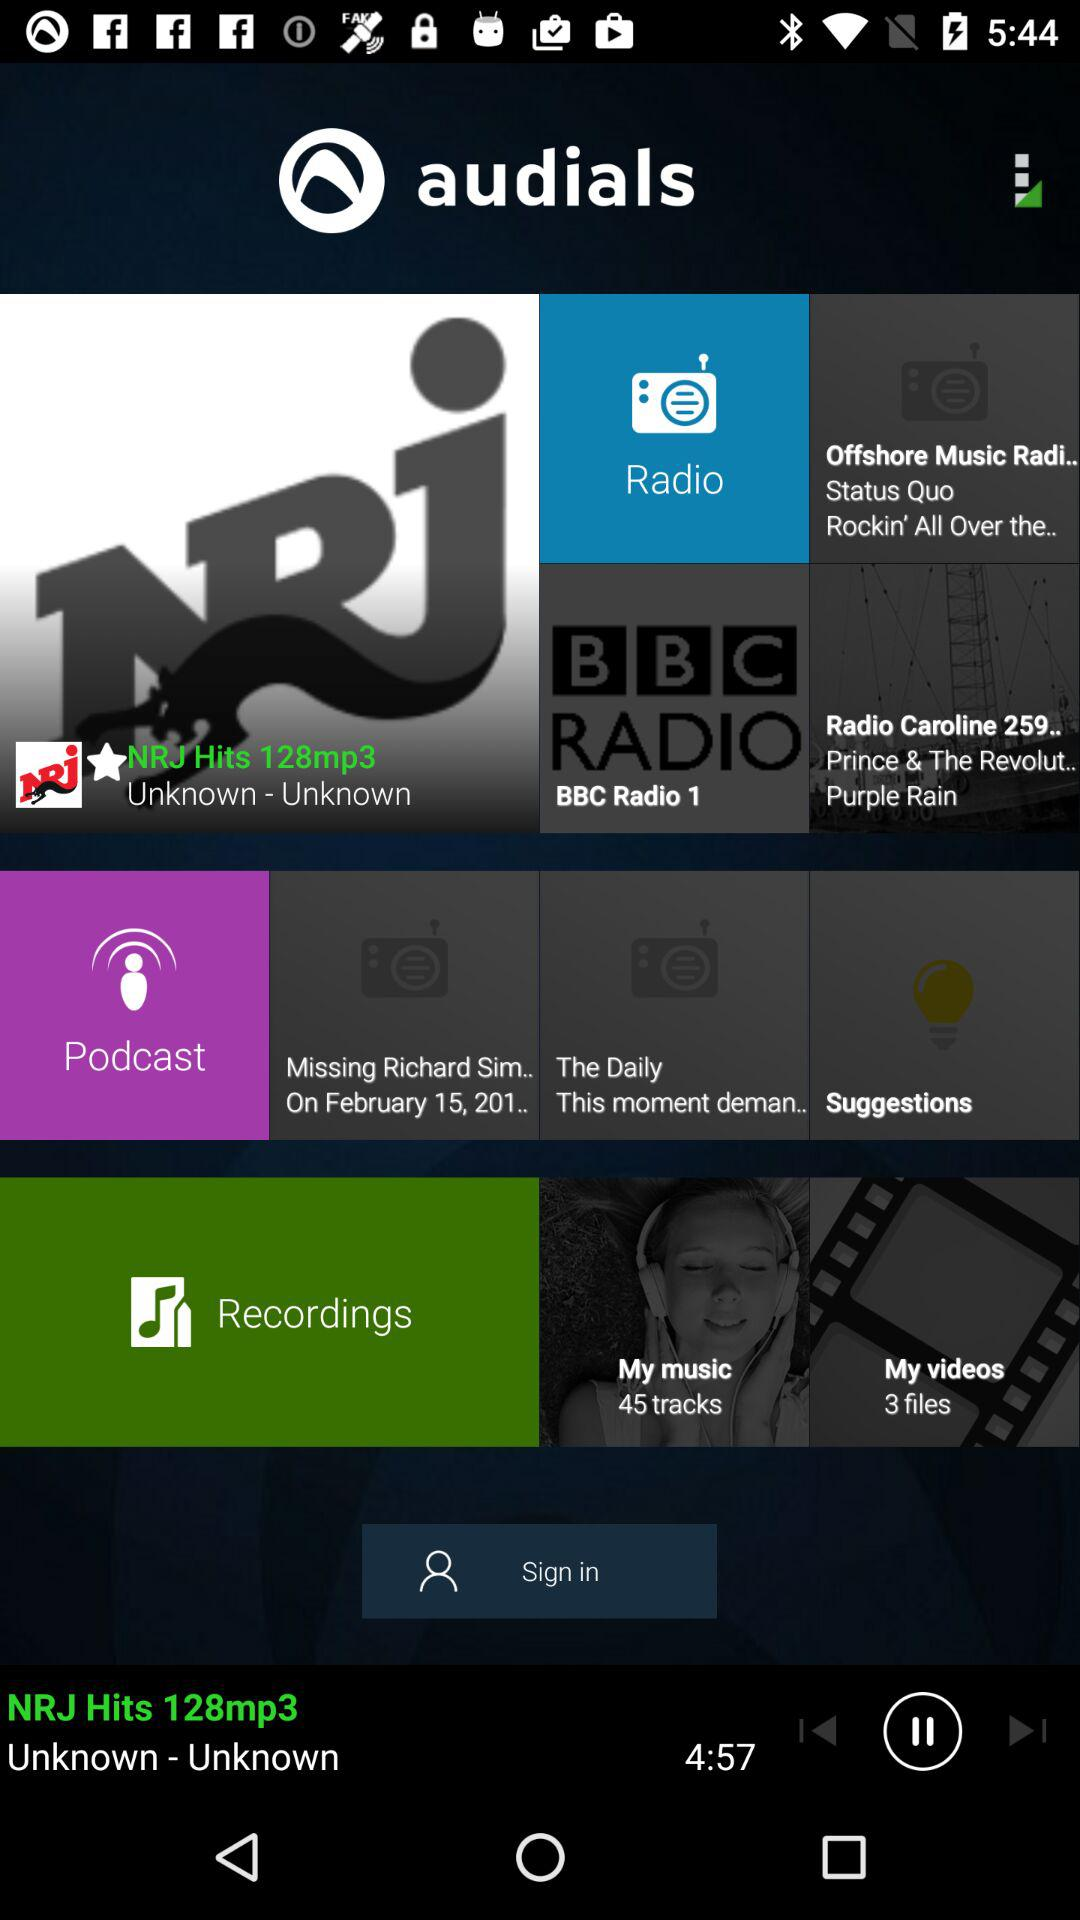How many files are present in "My videos"? The number of files in "My videos" is 3. 